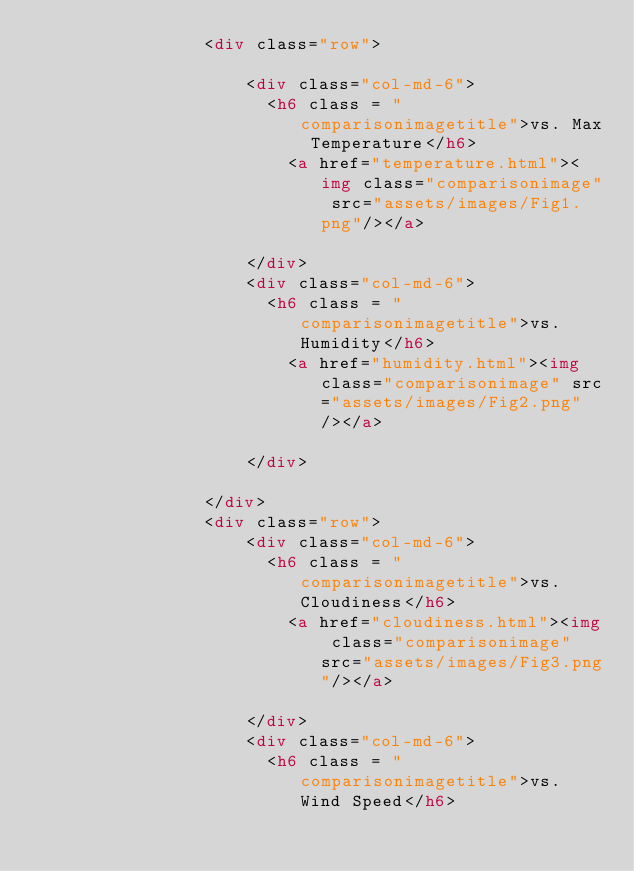Convert code to text. <code><loc_0><loc_0><loc_500><loc_500><_HTML_>                <div class="row">
                  
                    <div class="col-md-6">
                      <h6 class = "comparisonimagetitle">vs. Max Temperature</h6>
                        <a href="temperature.html"><img class="comparisonimage" src="assets/images/Fig1.png"/></a>

                    </div>
                    <div class="col-md-6">
                      <h6 class = "comparisonimagetitle">vs. Humidity</h6>
                        <a href="humidity.html"><img class="comparisonimage" src="assets/images/Fig2.png"/></a>

                    </div>

                </div>
                <div class="row">
                    <div class="col-md-6">
                      <h6 class = "comparisonimagetitle">vs. Cloudiness</h6>
                        <a href="cloudiness.html"><img class="comparisonimage" src="assets/images/Fig3.png"/></a>

                    </div>
                    <div class="col-md-6">
                      <h6 class = "comparisonimagetitle">vs. Wind Speed</h6></code> 